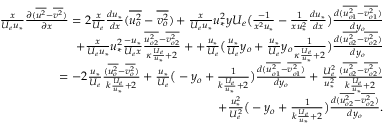<formula> <loc_0><loc_0><loc_500><loc_500>\begin{array} { r } { \frac { x } { U _ { e } u _ { * } } \frac { \partial ( \overline { { u ^ { 2 } } } - \overline { { v ^ { 2 } } } ) } { \partial x } = 2 \frac { x } { U _ { e } } \frac { d u _ { * } } { d x } ( \overline { { u _ { o } ^ { 2 } } } - \overline { { v _ { o } ^ { 2 } } } ) + \frac { x } { U _ { e } { u _ { * } } } u _ { * } ^ { 2 } y U _ { e } \left ( \frac { - 1 } { x ^ { 2 } u _ { * } } - { \frac { 1 } { x u _ { * } ^ { 2 } } \frac { d u _ { * } } { d x } } \right ) \frac { d ( \overline { { u _ { o 1 } ^ { 2 } } } - \overline { { v _ { o 1 } ^ { 2 } } } ) } { d y _ { o } } } \\ { + \frac { x } { U _ { e } u _ { * } } u _ { * } ^ { 2 } \frac { - u _ { * } } { U _ { e } x } \frac { \overline { { u _ { o 2 } ^ { 2 } } } - \overline { { v _ { o 2 } ^ { 2 } } } } { \kappa \frac { U _ { e } } { u _ { * } } + 2 } + + \frac { u _ { * } } { U _ { e } } \left ( \frac { u _ { * } } { U _ { e } } y _ { o } + \frac { u _ { * } } { U _ { e } } y _ { o } \frac { 1 } { \kappa \frac { U _ { e } } { u _ { * } } + 2 } \right ) \frac { d ( \overline { { u _ { o 2 } ^ { 2 } } } - \overline { { v _ { o 2 } ^ { 2 } } } ) } { d y _ { o } } } \\ { = - 2 \frac { u _ { * } } { U _ { e } } \frac { ( \overline { { u _ { o } ^ { 2 } } } - \overline { { v _ { o } ^ { 2 } } } ) } { k \frac { U _ { e } } { u _ { * } } + 2 } + \frac { u _ { * } } { U _ { e } } \left ( - y _ { o } + \frac { 1 } { k \frac { U _ { e } } { u _ { * } } + 2 } \right ) \frac { d ( \overline { { u _ { o 1 } ^ { 2 } } } - \overline { { v _ { o 1 } ^ { 2 } } } ) } { d y _ { o } } + \frac { U _ { e } ^ { 2 } } { u _ { * } ^ { 2 } } \frac { ( \overline { { u _ { o 2 } ^ { 2 } } } - \overline { { v _ { o 2 } ^ { 2 } } } ) } { k \frac { U _ { e } } { u _ { * } } + 2 } } \\ { + \frac { u _ { * } ^ { 2 } } { U _ { e } ^ { 2 } } \left ( - y _ { o } + \frac { 1 } { k \frac { U _ { e } } { u _ { * } } + 2 } \right ) \frac { d ( \overline { { u _ { o 2 } ^ { 2 } } } - \overline { { v _ { o 2 } ^ { 2 } } } ) } { d y _ { o } } . } \end{array}</formula> 